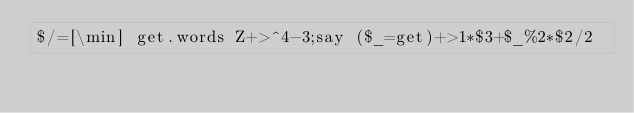<code> <loc_0><loc_0><loc_500><loc_500><_Perl_>$/=[\min] get.words Z+>^4-3;say ($_=get)+>1*$3+$_%2*$2/2</code> 